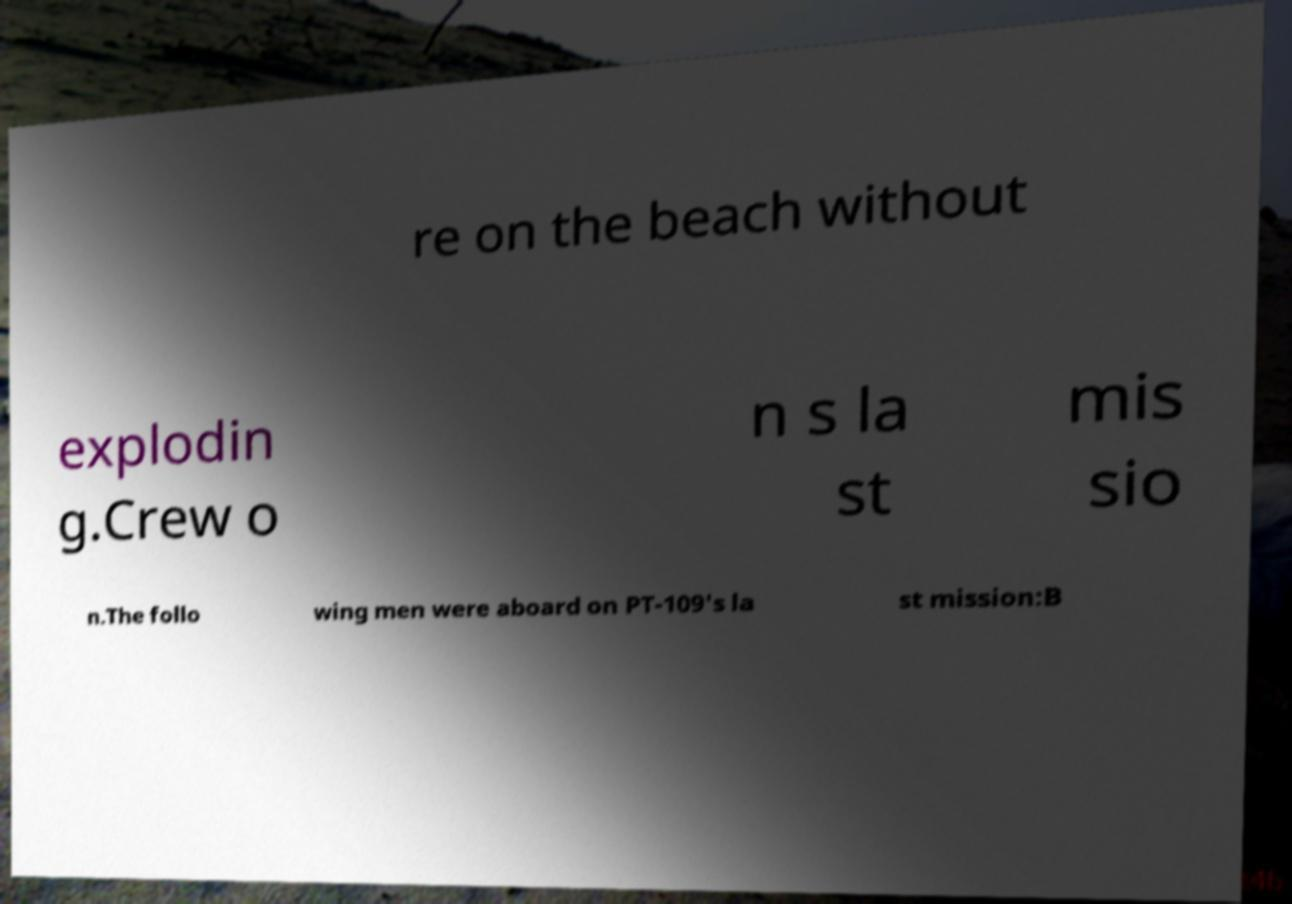Can you accurately transcribe the text from the provided image for me? re on the beach without explodin g.Crew o n s la st mis sio n.The follo wing men were aboard on PT-109's la st mission:B 